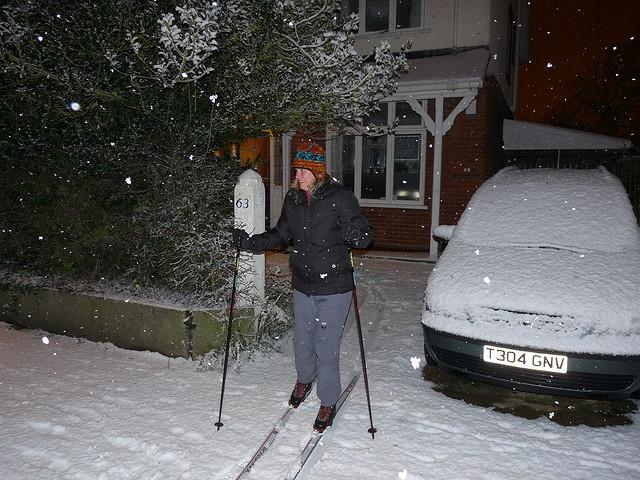What is the cars license plate number?
Answer briefly. T304 gnv. What is this person holding?
Give a very brief answer. Ski poles. What is the number on the pole?
Keep it brief. 63. Is it night time?
Keep it brief. Yes. 